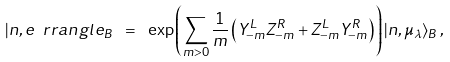<formula> <loc_0><loc_0><loc_500><loc_500>| n , e \ r r a n g l e _ { B } \ = \ \exp \left ( \sum _ { m > 0 } \frac { 1 } { m } \left ( Y ^ { L } _ { - m } Z ^ { R } _ { - m } + Z ^ { L } _ { - m } Y ^ { R } _ { - m } \right ) \right ) | n , \mu _ { \lambda } \rangle _ { B } \, , \\</formula> 